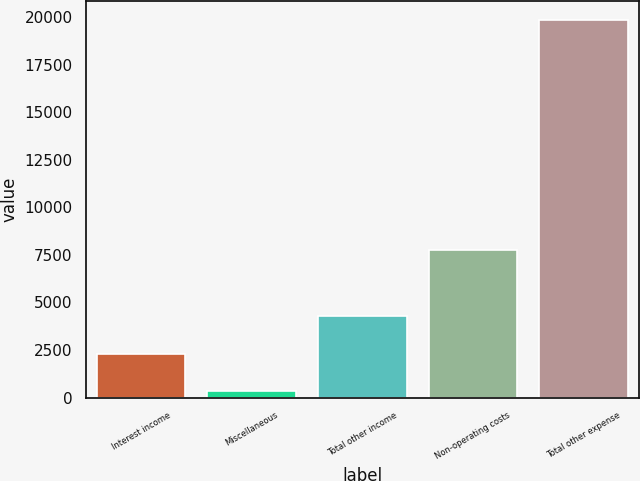<chart> <loc_0><loc_0><loc_500><loc_500><bar_chart><fcel>Interest income<fcel>Miscellaneous<fcel>Total other income<fcel>Non-operating costs<fcel>Total other expense<nl><fcel>2314.5<fcel>367<fcel>4262<fcel>7777<fcel>19842<nl></chart> 